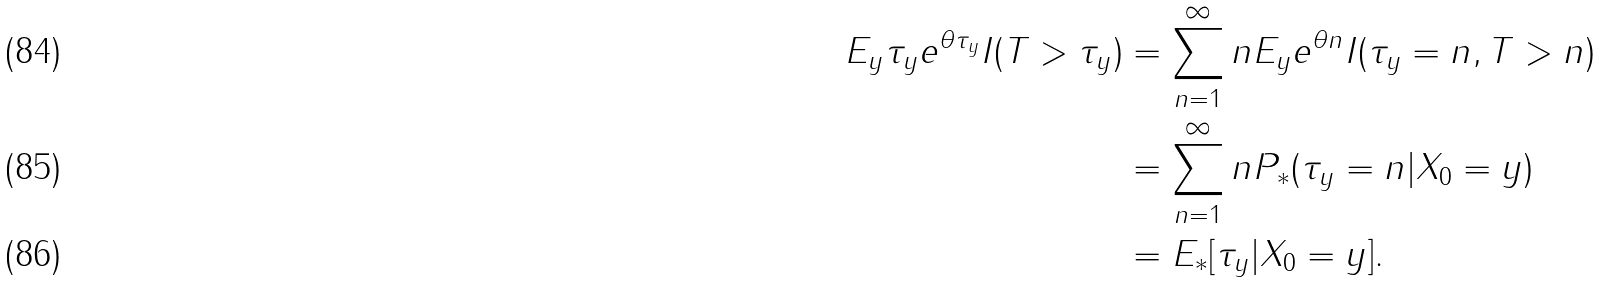Convert formula to latex. <formula><loc_0><loc_0><loc_500><loc_500>E _ { y } \tau _ { y } e ^ { \theta \tau _ { y } } I ( T > \tau _ { y } ) & = \sum _ { n = 1 } ^ { \infty } n E _ { y } e ^ { \theta n } I ( \tau _ { y } = n , T > n ) \\ & = \sum _ { n = 1 } ^ { \infty } n P _ { * } ( \tau _ { y } = n | X _ { 0 } = y ) \\ & = E _ { * } [ \tau _ { y } | X _ { 0 } = y ] .</formula> 